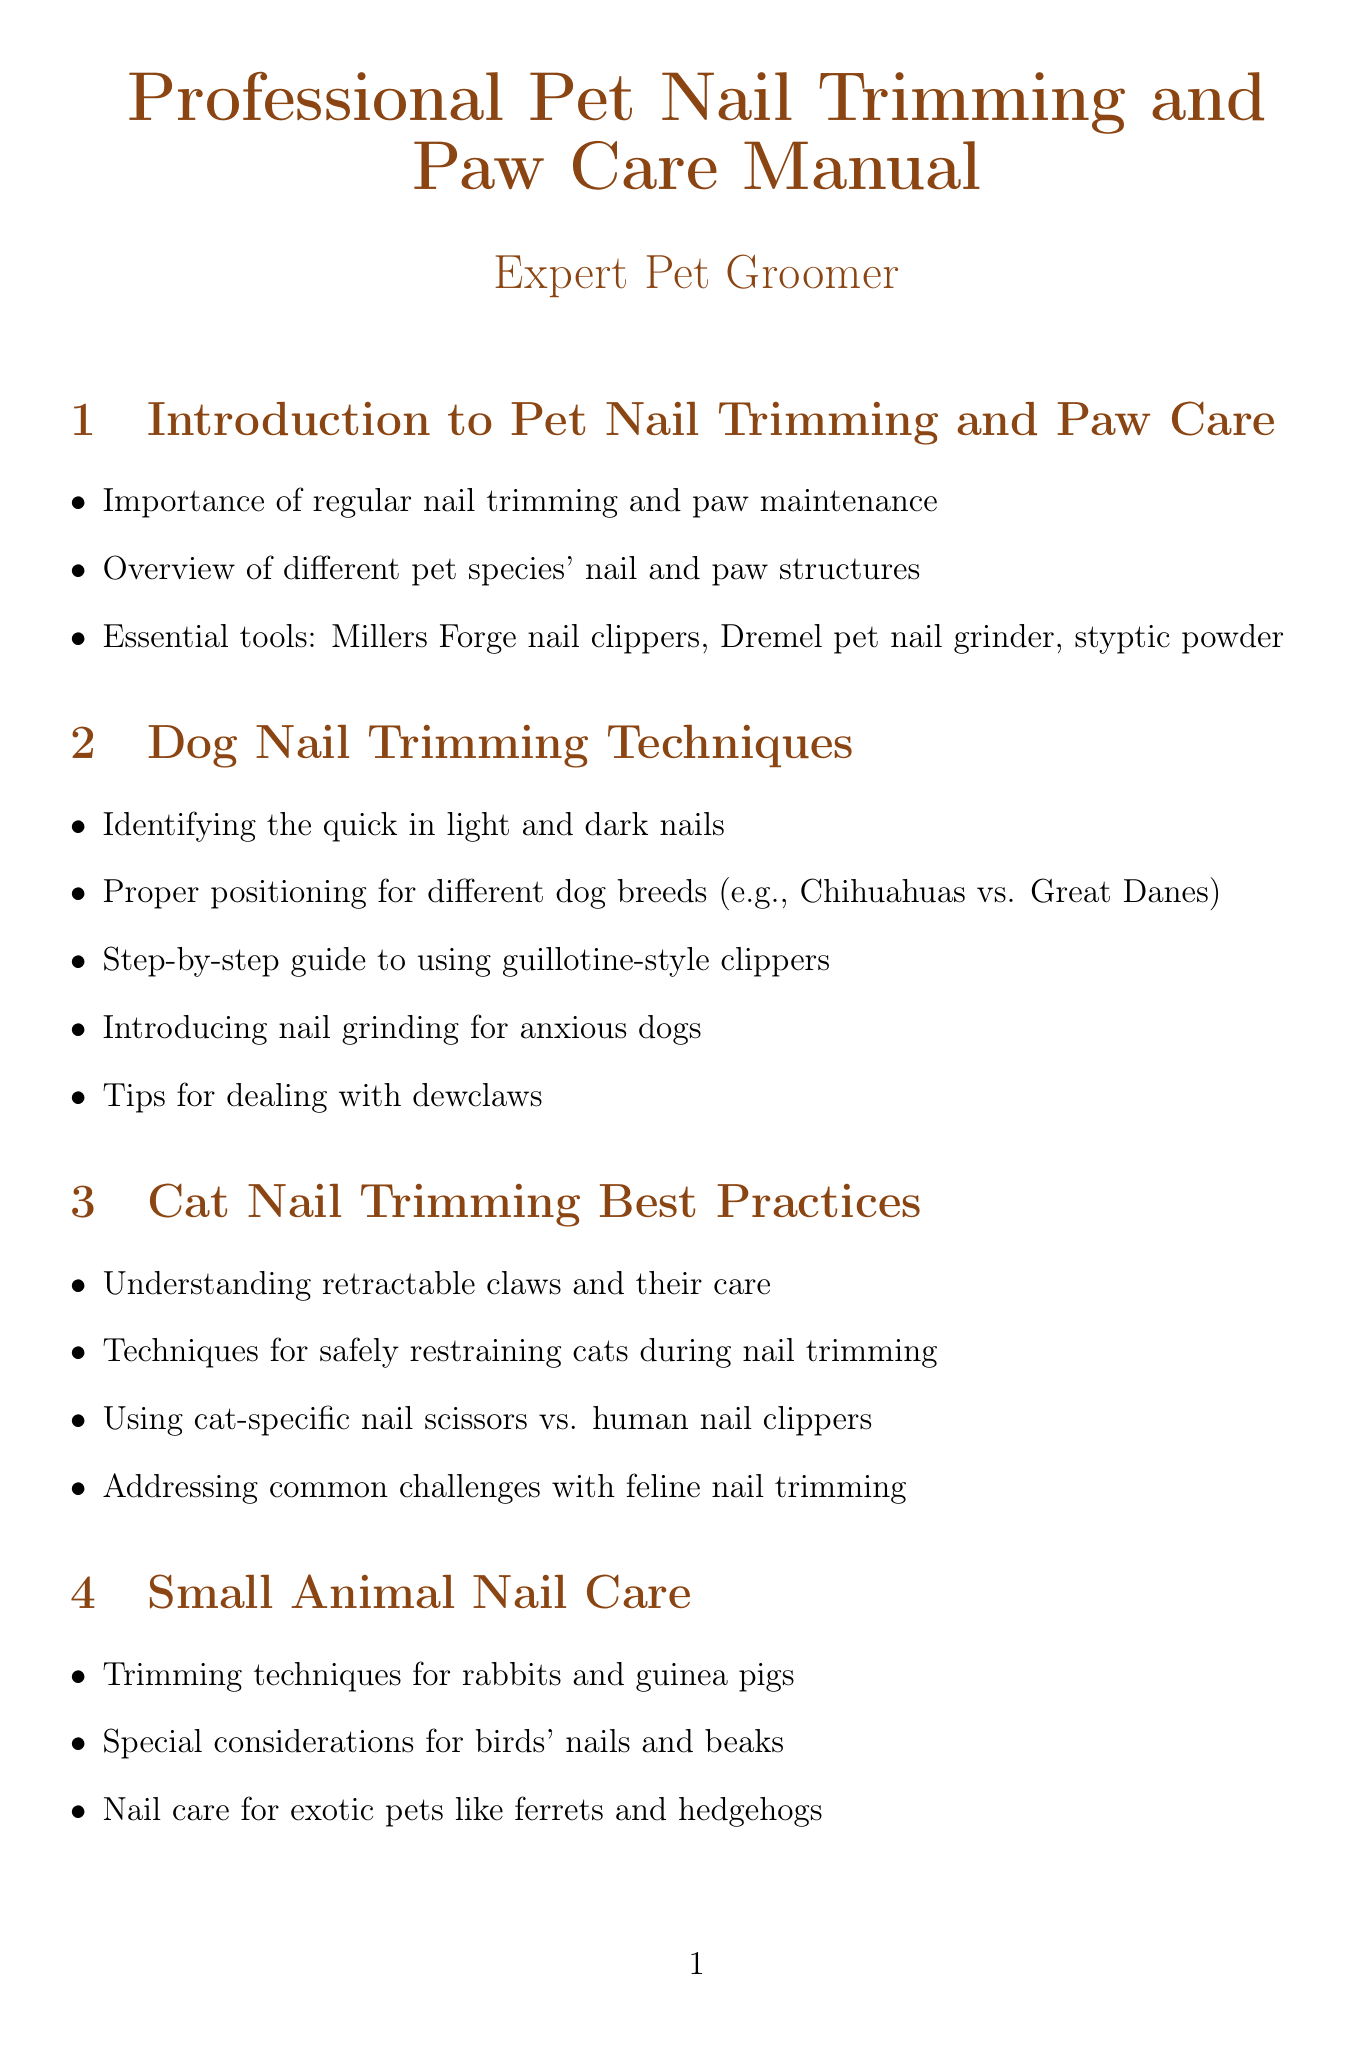What is the first section of the manual? The first section titled is about the introduction to pet nail trimming and paw care.
Answer: Introduction to Pet Nail Trimming and Paw Care What tool is specifically mentioned for treating quick bleeding? The document mentions a specific tool used during emergencies when the quick is accidentally cut.
Answer: Styptic powder What is one technique for trimming nails of anxious dogs? The document discusses an alternative method that can be helpful for anxious dogs during nail trimming.
Answer: Nail grinding What should pet owners be taught for home care? This refers to basic techniques that pet owners need to know for maintaining their pets' nails.
Answer: Basic nail maintenance techniques What product is recommended for protecting paw pads? The document lists a specific product that can be used to protect a pet's paw pads from injuries and dryness.
Answer: Musher's Secret How many case studies are included in the manual? The document mentions a specific count of case studies related to nail trimming experiences.
Answer: Two Which section covers best practices for nail trimming cats? This refers to the section dedicated to techniques and practices specifically for feline grooming.
Answer: Cat Nail Trimming Best Practices What type of clippers are suggested for large breed dogs? The document specifies a type of nail trimmer that is particularly suitable for large dog breeds.
Answer: Safari Professional nail trimmers 